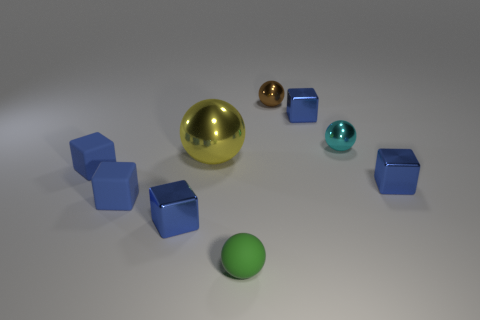There is a metallic thing that is in front of the large metallic ball and on the right side of the green rubber thing; what is its shape?
Your answer should be compact. Cube. Are there the same number of rubber spheres behind the tiny green thing and blue things on the left side of the tiny brown thing?
Keep it short and to the point. No. Is there a big blue object made of the same material as the tiny brown thing?
Offer a terse response. No. Does the small cube that is behind the large yellow metallic object have the same material as the big yellow ball?
Offer a very short reply. Yes. There is a metal object that is right of the green rubber sphere and in front of the big yellow object; how big is it?
Give a very brief answer. Small. The tiny rubber sphere is what color?
Provide a short and direct response. Green. What number of small rubber things are there?
Offer a terse response. 3. There is a small metallic object that is left of the small green thing; is it the same shape as the small blue metallic object that is behind the big thing?
Your response must be concise. Yes. There is a tiny metallic object left of the matte object in front of the metal block to the left of the large yellow shiny ball; what color is it?
Ensure brevity in your answer.  Blue. The small metal sphere that is on the right side of the small brown metal thing is what color?
Offer a very short reply. Cyan. 